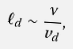Convert formula to latex. <formula><loc_0><loc_0><loc_500><loc_500>\ell _ { d } \sim \frac { \nu } { v _ { d } } ,</formula> 